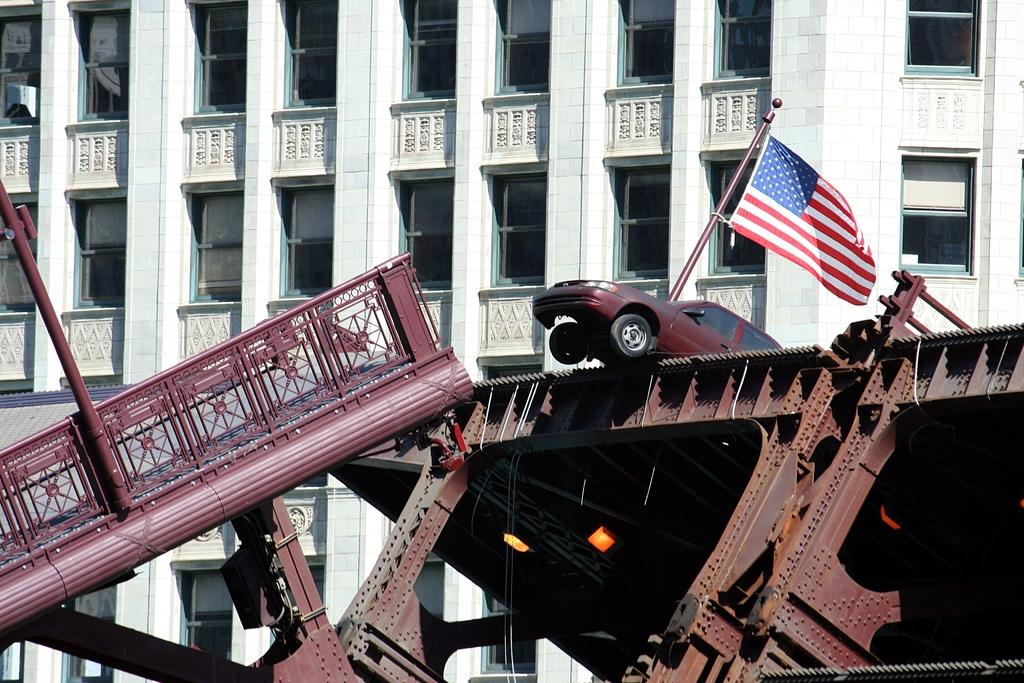What type of structure is present in the image? There is a metal construction in the image. What is located above the metal construction? There is a car and a flag above the metal construction. What can be seen in the background of the image? There is a huge building in the background of the image. How many pigs are visible in the image? There are no pigs present in the image. What type of friction can be observed between the car and the metal construction in the image? There is no indication of friction between the car and the metal construction in the image, as they are not in contact with each other. 